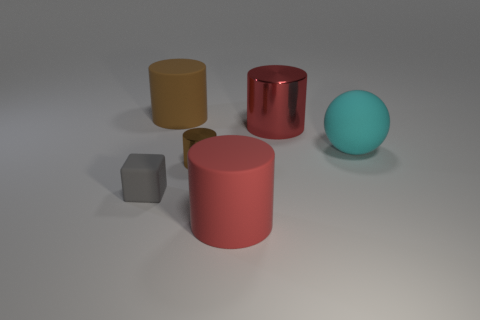There is a matte thing that is to the left of the brown cylinder on the left side of the brown metal object that is on the right side of the cube; what is its shape? The matte object located to the left of the brown cylinder, which itself is on the left side of the shiny brown metal object towards the right of the cube, has a cylindrical shape. It appears like a smaller cylinder with a circular top and is colored yellow. 